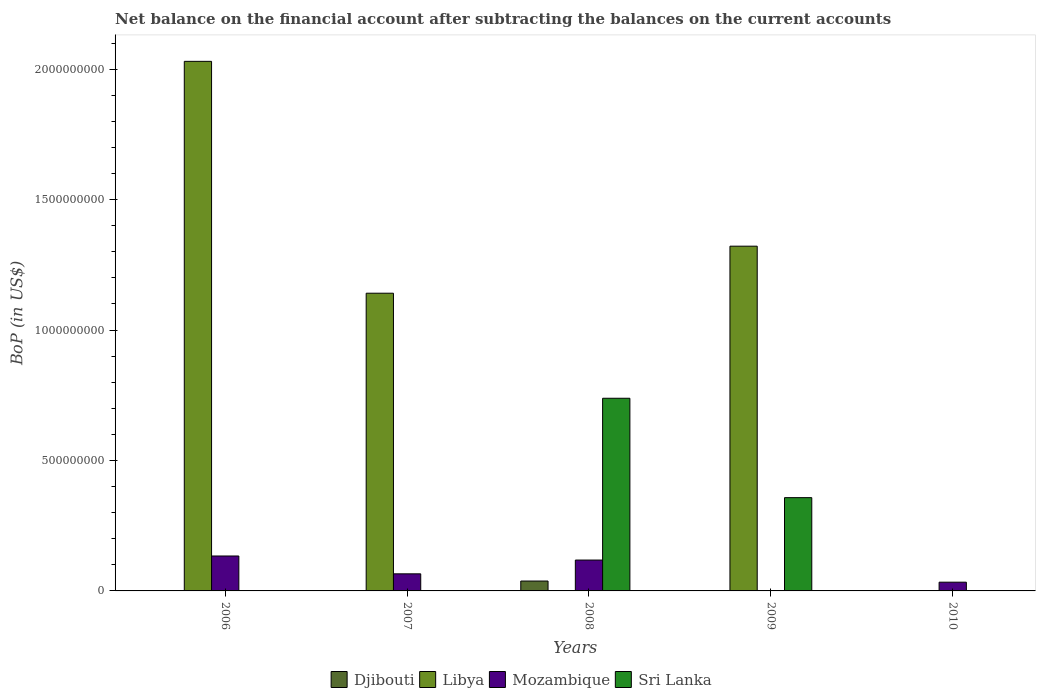Are the number of bars per tick equal to the number of legend labels?
Ensure brevity in your answer.  No. Are the number of bars on each tick of the X-axis equal?
Your answer should be very brief. No. How many bars are there on the 5th tick from the left?
Keep it short and to the point. 1. What is the label of the 2nd group of bars from the left?
Ensure brevity in your answer.  2007. In how many cases, is the number of bars for a given year not equal to the number of legend labels?
Provide a short and direct response. 5. What is the Balance of Payments in Libya in 2010?
Provide a succinct answer. 0. Across all years, what is the maximum Balance of Payments in Libya?
Offer a terse response. 2.03e+09. What is the total Balance of Payments in Libya in the graph?
Offer a terse response. 4.49e+09. What is the difference between the Balance of Payments in Mozambique in 2007 and that in 2008?
Your response must be concise. -5.28e+07. What is the difference between the Balance of Payments in Libya in 2007 and the Balance of Payments in Djibouti in 2006?
Your response must be concise. 1.14e+09. What is the average Balance of Payments in Libya per year?
Give a very brief answer. 8.99e+08. In the year 2008, what is the difference between the Balance of Payments in Djibouti and Balance of Payments in Mozambique?
Ensure brevity in your answer.  -8.05e+07. In how many years, is the Balance of Payments in Libya greater than 1300000000 US$?
Your answer should be very brief. 2. What is the ratio of the Balance of Payments in Mozambique in 2008 to that in 2010?
Make the answer very short. 3.53. What is the difference between the highest and the second highest Balance of Payments in Libya?
Provide a succinct answer. 7.08e+08. What is the difference between the highest and the lowest Balance of Payments in Libya?
Make the answer very short. 2.03e+09. In how many years, is the Balance of Payments in Mozambique greater than the average Balance of Payments in Mozambique taken over all years?
Make the answer very short. 2. Is it the case that in every year, the sum of the Balance of Payments in Sri Lanka and Balance of Payments in Mozambique is greater than the sum of Balance of Payments in Libya and Balance of Payments in Djibouti?
Give a very brief answer. No. How many years are there in the graph?
Offer a terse response. 5. What is the difference between two consecutive major ticks on the Y-axis?
Offer a very short reply. 5.00e+08. Does the graph contain any zero values?
Give a very brief answer. Yes. Where does the legend appear in the graph?
Your answer should be very brief. Bottom center. How many legend labels are there?
Your answer should be compact. 4. What is the title of the graph?
Give a very brief answer. Net balance on the financial account after subtracting the balances on the current accounts. Does "Jordan" appear as one of the legend labels in the graph?
Offer a very short reply. No. What is the label or title of the X-axis?
Your response must be concise. Years. What is the label or title of the Y-axis?
Make the answer very short. BoP (in US$). What is the BoP (in US$) in Libya in 2006?
Make the answer very short. 2.03e+09. What is the BoP (in US$) in Mozambique in 2006?
Offer a very short reply. 1.34e+08. What is the BoP (in US$) in Sri Lanka in 2006?
Provide a succinct answer. 0. What is the BoP (in US$) in Libya in 2007?
Ensure brevity in your answer.  1.14e+09. What is the BoP (in US$) of Mozambique in 2007?
Provide a short and direct response. 6.55e+07. What is the BoP (in US$) of Djibouti in 2008?
Keep it short and to the point. 3.79e+07. What is the BoP (in US$) in Libya in 2008?
Make the answer very short. 0. What is the BoP (in US$) of Mozambique in 2008?
Make the answer very short. 1.18e+08. What is the BoP (in US$) of Sri Lanka in 2008?
Offer a terse response. 7.39e+08. What is the BoP (in US$) in Libya in 2009?
Your answer should be compact. 1.32e+09. What is the BoP (in US$) in Mozambique in 2009?
Your answer should be compact. 0. What is the BoP (in US$) in Sri Lanka in 2009?
Ensure brevity in your answer.  3.58e+08. What is the BoP (in US$) in Djibouti in 2010?
Give a very brief answer. 0. What is the BoP (in US$) in Libya in 2010?
Your response must be concise. 0. What is the BoP (in US$) in Mozambique in 2010?
Ensure brevity in your answer.  3.35e+07. What is the BoP (in US$) of Sri Lanka in 2010?
Your answer should be compact. 0. Across all years, what is the maximum BoP (in US$) of Djibouti?
Provide a succinct answer. 3.79e+07. Across all years, what is the maximum BoP (in US$) of Libya?
Your answer should be very brief. 2.03e+09. Across all years, what is the maximum BoP (in US$) in Mozambique?
Your answer should be compact. 1.34e+08. Across all years, what is the maximum BoP (in US$) in Sri Lanka?
Keep it short and to the point. 7.39e+08. Across all years, what is the minimum BoP (in US$) in Libya?
Provide a short and direct response. 0. Across all years, what is the minimum BoP (in US$) in Sri Lanka?
Offer a very short reply. 0. What is the total BoP (in US$) in Djibouti in the graph?
Provide a succinct answer. 3.79e+07. What is the total BoP (in US$) in Libya in the graph?
Offer a very short reply. 4.49e+09. What is the total BoP (in US$) of Mozambique in the graph?
Your answer should be compact. 3.51e+08. What is the total BoP (in US$) of Sri Lanka in the graph?
Your answer should be very brief. 1.10e+09. What is the difference between the BoP (in US$) of Libya in 2006 and that in 2007?
Ensure brevity in your answer.  8.89e+08. What is the difference between the BoP (in US$) of Mozambique in 2006 and that in 2007?
Your answer should be compact. 6.84e+07. What is the difference between the BoP (in US$) in Mozambique in 2006 and that in 2008?
Keep it short and to the point. 1.55e+07. What is the difference between the BoP (in US$) of Libya in 2006 and that in 2009?
Your response must be concise. 7.08e+08. What is the difference between the BoP (in US$) in Mozambique in 2006 and that in 2010?
Give a very brief answer. 1.00e+08. What is the difference between the BoP (in US$) of Mozambique in 2007 and that in 2008?
Keep it short and to the point. -5.28e+07. What is the difference between the BoP (in US$) of Libya in 2007 and that in 2009?
Make the answer very short. -1.80e+08. What is the difference between the BoP (in US$) of Mozambique in 2007 and that in 2010?
Provide a short and direct response. 3.20e+07. What is the difference between the BoP (in US$) of Sri Lanka in 2008 and that in 2009?
Ensure brevity in your answer.  3.81e+08. What is the difference between the BoP (in US$) of Mozambique in 2008 and that in 2010?
Offer a terse response. 8.48e+07. What is the difference between the BoP (in US$) of Libya in 2006 and the BoP (in US$) of Mozambique in 2007?
Offer a terse response. 1.96e+09. What is the difference between the BoP (in US$) of Libya in 2006 and the BoP (in US$) of Mozambique in 2008?
Provide a succinct answer. 1.91e+09. What is the difference between the BoP (in US$) of Libya in 2006 and the BoP (in US$) of Sri Lanka in 2008?
Keep it short and to the point. 1.29e+09. What is the difference between the BoP (in US$) of Mozambique in 2006 and the BoP (in US$) of Sri Lanka in 2008?
Ensure brevity in your answer.  -6.05e+08. What is the difference between the BoP (in US$) in Libya in 2006 and the BoP (in US$) in Sri Lanka in 2009?
Give a very brief answer. 1.67e+09. What is the difference between the BoP (in US$) of Mozambique in 2006 and the BoP (in US$) of Sri Lanka in 2009?
Provide a succinct answer. -2.24e+08. What is the difference between the BoP (in US$) of Libya in 2006 and the BoP (in US$) of Mozambique in 2010?
Your answer should be compact. 2.00e+09. What is the difference between the BoP (in US$) of Libya in 2007 and the BoP (in US$) of Mozambique in 2008?
Your answer should be very brief. 1.02e+09. What is the difference between the BoP (in US$) in Libya in 2007 and the BoP (in US$) in Sri Lanka in 2008?
Give a very brief answer. 4.03e+08. What is the difference between the BoP (in US$) of Mozambique in 2007 and the BoP (in US$) of Sri Lanka in 2008?
Provide a succinct answer. -6.73e+08. What is the difference between the BoP (in US$) in Libya in 2007 and the BoP (in US$) in Sri Lanka in 2009?
Offer a very short reply. 7.84e+08. What is the difference between the BoP (in US$) of Mozambique in 2007 and the BoP (in US$) of Sri Lanka in 2009?
Your answer should be very brief. -2.92e+08. What is the difference between the BoP (in US$) in Libya in 2007 and the BoP (in US$) in Mozambique in 2010?
Offer a very short reply. 1.11e+09. What is the difference between the BoP (in US$) of Djibouti in 2008 and the BoP (in US$) of Libya in 2009?
Give a very brief answer. -1.28e+09. What is the difference between the BoP (in US$) of Djibouti in 2008 and the BoP (in US$) of Sri Lanka in 2009?
Your response must be concise. -3.20e+08. What is the difference between the BoP (in US$) in Mozambique in 2008 and the BoP (in US$) in Sri Lanka in 2009?
Ensure brevity in your answer.  -2.39e+08. What is the difference between the BoP (in US$) of Djibouti in 2008 and the BoP (in US$) of Mozambique in 2010?
Ensure brevity in your answer.  4.36e+06. What is the difference between the BoP (in US$) in Libya in 2009 and the BoP (in US$) in Mozambique in 2010?
Offer a very short reply. 1.29e+09. What is the average BoP (in US$) in Djibouti per year?
Make the answer very short. 7.58e+06. What is the average BoP (in US$) of Libya per year?
Provide a short and direct response. 8.99e+08. What is the average BoP (in US$) in Mozambique per year?
Give a very brief answer. 7.03e+07. What is the average BoP (in US$) of Sri Lanka per year?
Your answer should be compact. 2.19e+08. In the year 2006, what is the difference between the BoP (in US$) in Libya and BoP (in US$) in Mozambique?
Make the answer very short. 1.90e+09. In the year 2007, what is the difference between the BoP (in US$) of Libya and BoP (in US$) of Mozambique?
Your answer should be very brief. 1.08e+09. In the year 2008, what is the difference between the BoP (in US$) of Djibouti and BoP (in US$) of Mozambique?
Give a very brief answer. -8.05e+07. In the year 2008, what is the difference between the BoP (in US$) of Djibouti and BoP (in US$) of Sri Lanka?
Your answer should be compact. -7.01e+08. In the year 2008, what is the difference between the BoP (in US$) of Mozambique and BoP (in US$) of Sri Lanka?
Offer a terse response. -6.20e+08. In the year 2009, what is the difference between the BoP (in US$) of Libya and BoP (in US$) of Sri Lanka?
Offer a terse response. 9.64e+08. What is the ratio of the BoP (in US$) in Libya in 2006 to that in 2007?
Offer a terse response. 1.78. What is the ratio of the BoP (in US$) in Mozambique in 2006 to that in 2007?
Provide a short and direct response. 2.04. What is the ratio of the BoP (in US$) of Mozambique in 2006 to that in 2008?
Provide a succinct answer. 1.13. What is the ratio of the BoP (in US$) in Libya in 2006 to that in 2009?
Keep it short and to the point. 1.54. What is the ratio of the BoP (in US$) in Mozambique in 2006 to that in 2010?
Provide a short and direct response. 3.99. What is the ratio of the BoP (in US$) of Mozambique in 2007 to that in 2008?
Provide a short and direct response. 0.55. What is the ratio of the BoP (in US$) of Libya in 2007 to that in 2009?
Provide a succinct answer. 0.86. What is the ratio of the BoP (in US$) in Mozambique in 2007 to that in 2010?
Provide a succinct answer. 1.95. What is the ratio of the BoP (in US$) in Sri Lanka in 2008 to that in 2009?
Your answer should be compact. 2.07. What is the ratio of the BoP (in US$) in Mozambique in 2008 to that in 2010?
Your answer should be very brief. 3.53. What is the difference between the highest and the second highest BoP (in US$) of Libya?
Your answer should be very brief. 7.08e+08. What is the difference between the highest and the second highest BoP (in US$) in Mozambique?
Offer a terse response. 1.55e+07. What is the difference between the highest and the lowest BoP (in US$) in Djibouti?
Provide a short and direct response. 3.79e+07. What is the difference between the highest and the lowest BoP (in US$) of Libya?
Ensure brevity in your answer.  2.03e+09. What is the difference between the highest and the lowest BoP (in US$) in Mozambique?
Your answer should be very brief. 1.34e+08. What is the difference between the highest and the lowest BoP (in US$) of Sri Lanka?
Offer a very short reply. 7.39e+08. 